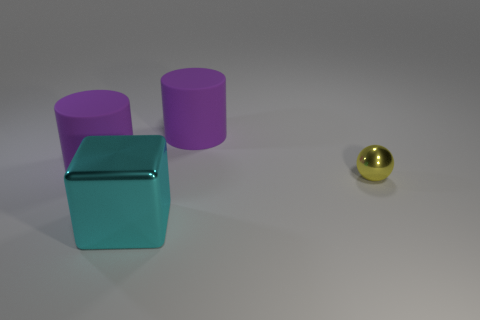Is there anything else that has the same size as the yellow object?
Ensure brevity in your answer.  No. There is a purple rubber thing that is on the left side of the shiny cube; is it the same size as the yellow metallic thing?
Make the answer very short. No. Is the number of big purple cylinders that are left of the small sphere greater than the number of large shiny blocks that are on the left side of the cyan shiny cube?
Your answer should be very brief. Yes. What color is the big rubber cylinder right of the big purple matte cylinder left of the shiny object in front of the yellow shiny sphere?
Keep it short and to the point. Purple. How many other things are there of the same color as the large shiny cube?
Your answer should be very brief. 0. How many things are either large metallic objects or yellow things?
Provide a short and direct response. 2. What number of objects are either yellow objects or small metal spheres to the right of the cyan metallic cube?
Provide a succinct answer. 1. Are the big cyan thing and the small thing made of the same material?
Make the answer very short. Yes. How many other things are there of the same material as the small yellow ball?
Your answer should be compact. 1. Are there more big rubber cylinders than large shiny things?
Provide a short and direct response. Yes. 